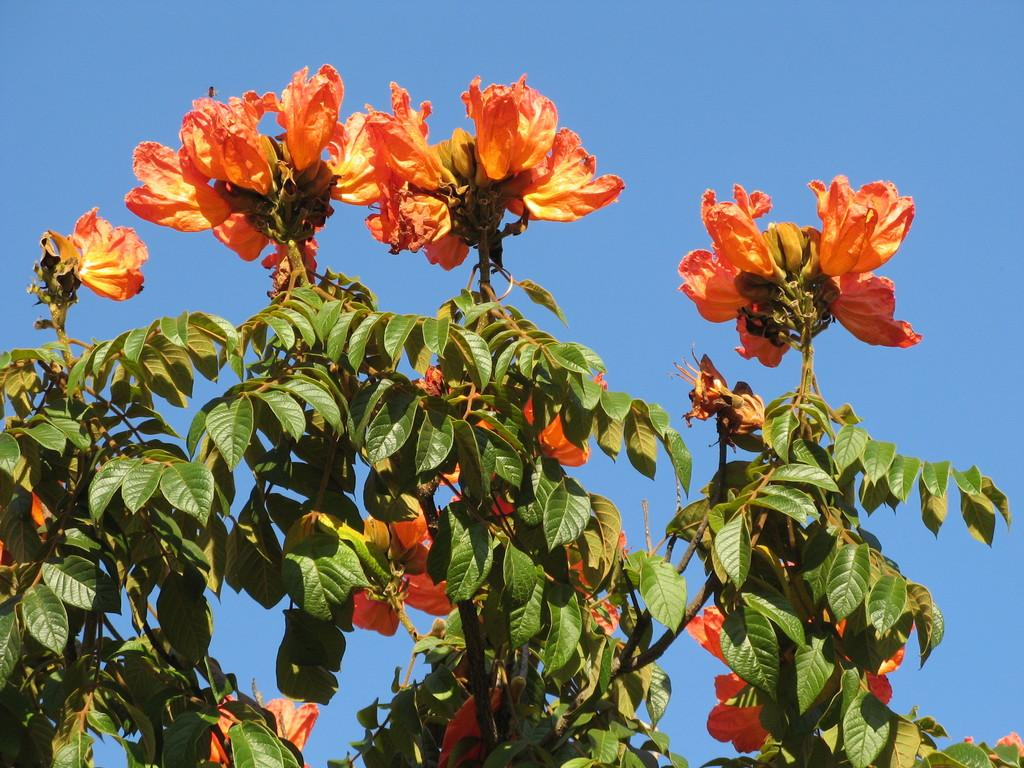What is located in the middle of the image? There are trees and flowers in the middle of the image. What can be seen behind the trees in the image? The sky is visible behind the trees. How many dogs are present in the image? There are no dogs present in the image; it features trees, flowers, and the sky. What type of profit can be seen in the image? There is no profit present in the image; it is a nature scene with trees, flowers, and the sky. 